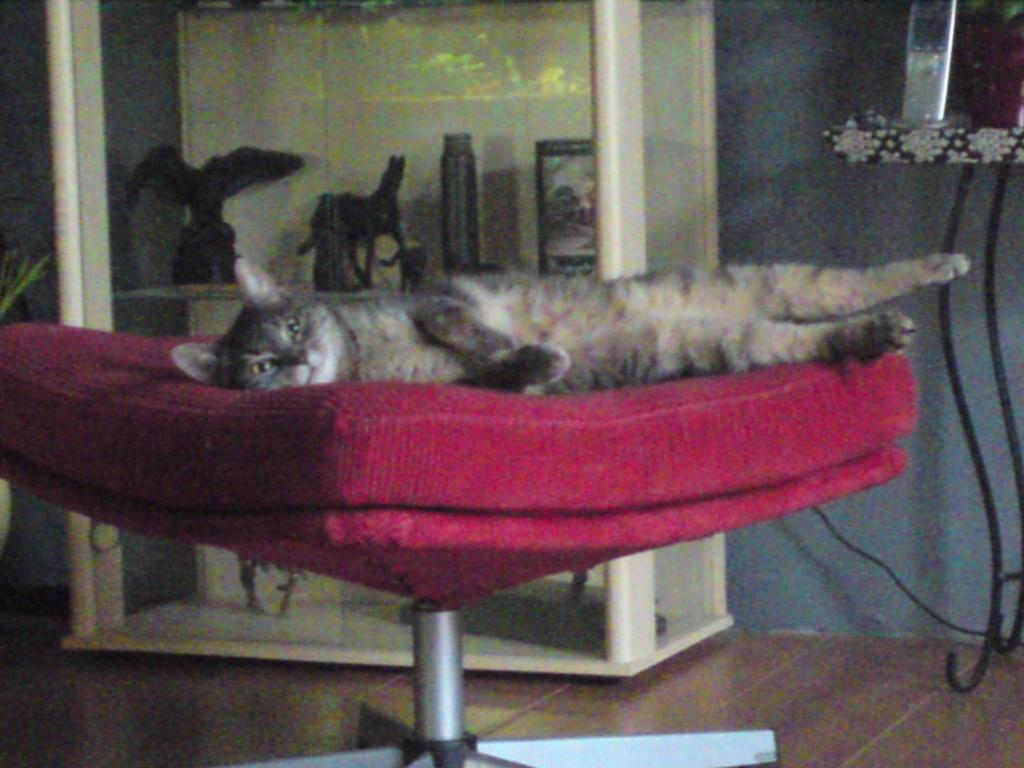What animal can be seen in the image? There is a cat in the image. What is the cat doing in the image? The cat is sleeping on a chair. What type of furniture is the cat resting on? The cat is sleeping on a chair. What is located behind the cat in the image? There is a cupboard with objects in the image. What electronic device is present in the image? There is a mobile phone on a table in the image. What type of fruit is being used as a stamp on the cat's back in the image? There is no fruit or stamp present on the cat's back in the image. 